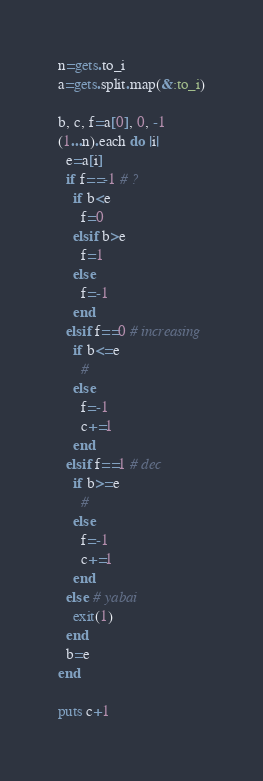<code> <loc_0><loc_0><loc_500><loc_500><_Ruby_>n=gets.to_i
a=gets.split.map(&:to_i)

b, c, f=a[0], 0, -1
(1...n).each do |i|
  e=a[i]
  if f==-1 # ?
    if b<e
      f=0
    elsif b>e
      f=1
    else
      f=-1
    end
  elsif f==0 # increasing
    if b<=e
      #
    else
      f=-1
      c+=1
    end
  elsif f==1 # dec
    if b>=e
      #
    else
      f=-1
      c+=1
    end
  else # yabai
    exit(1)
  end
  b=e
end

puts c+1
</code> 